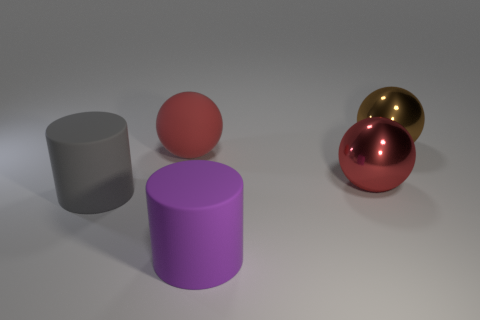What number of large green shiny spheres are there? There are no large green shiny spheres in the image. The objects present include a grey cylinder, a pink sphere, a purple cylinder, and two shiny spheres, one red and one gold. 